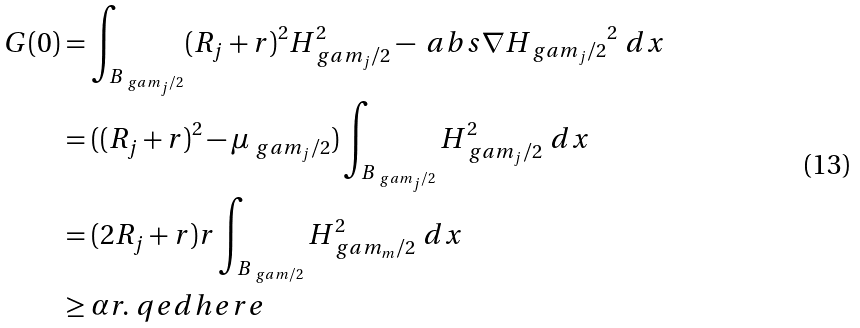<formula> <loc_0><loc_0><loc_500><loc_500>G ( 0 ) & = \int _ { B _ { \ g a m _ { j } / 2 } } ( R _ { j } + r ) ^ { 2 } H _ { \ g a m _ { j } / 2 } ^ { 2 } - \ a b s { \nabla H _ { \ g a m _ { j } / 2 } } ^ { 2 } \ d x \\ & = ( ( R _ { j } + r ) ^ { 2 } - \mu _ { \ g a m _ { j } / 2 } ) \int _ { B _ { \ g a m _ { j } / 2 } } H _ { \ g a m _ { j } / 2 } ^ { 2 } \ d x \\ & = ( 2 R _ { j } + r ) r \int _ { B _ { \ g a m / 2 } } H _ { \ g a m _ { m } / 2 } ^ { 2 } \ d x \\ & \geq \alpha r . \ q e d h e r e</formula> 